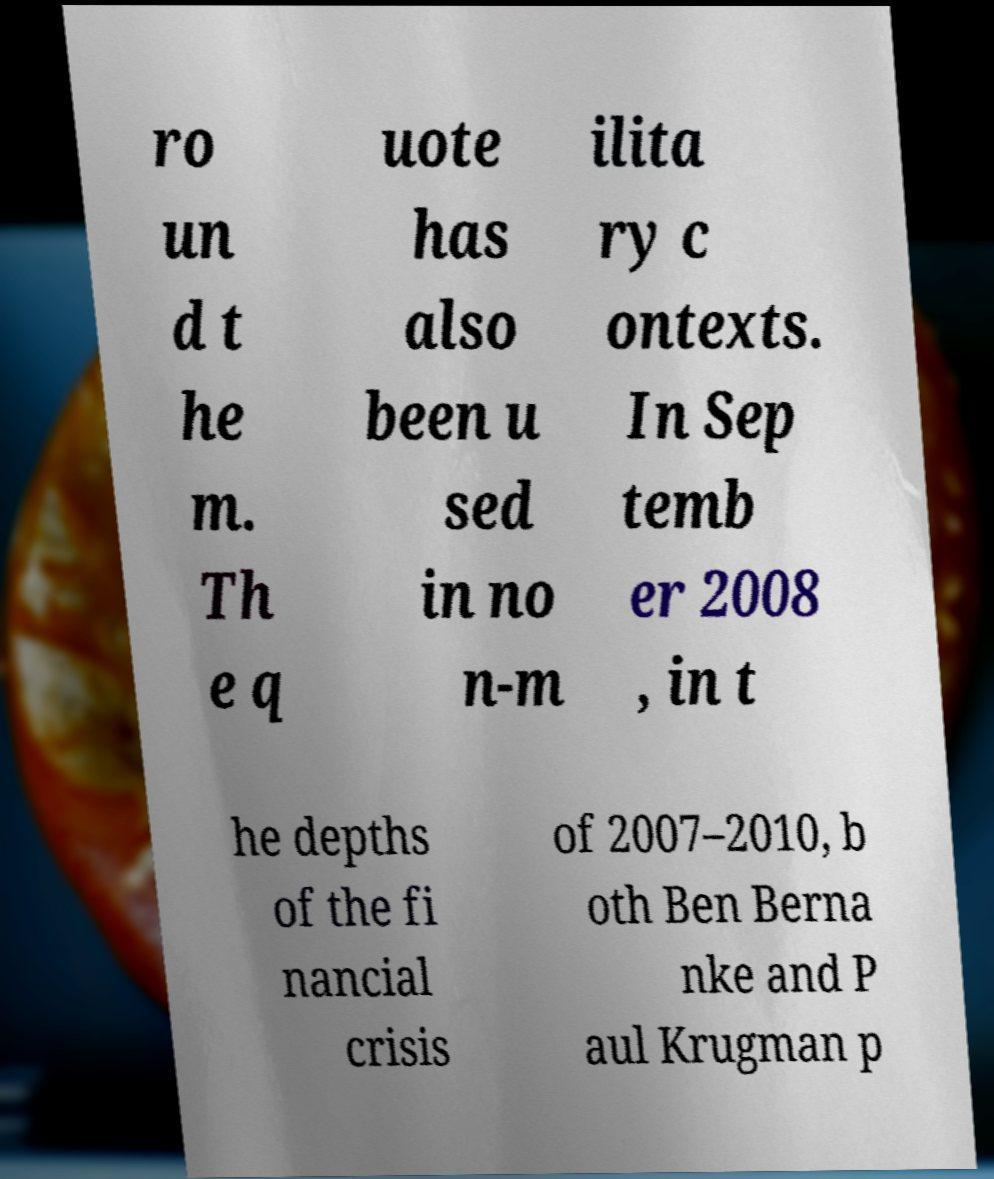I need the written content from this picture converted into text. Can you do that? ro un d t he m. Th e q uote has also been u sed in no n-m ilita ry c ontexts. In Sep temb er 2008 , in t he depths of the fi nancial crisis of 2007–2010, b oth Ben Berna nke and P aul Krugman p 